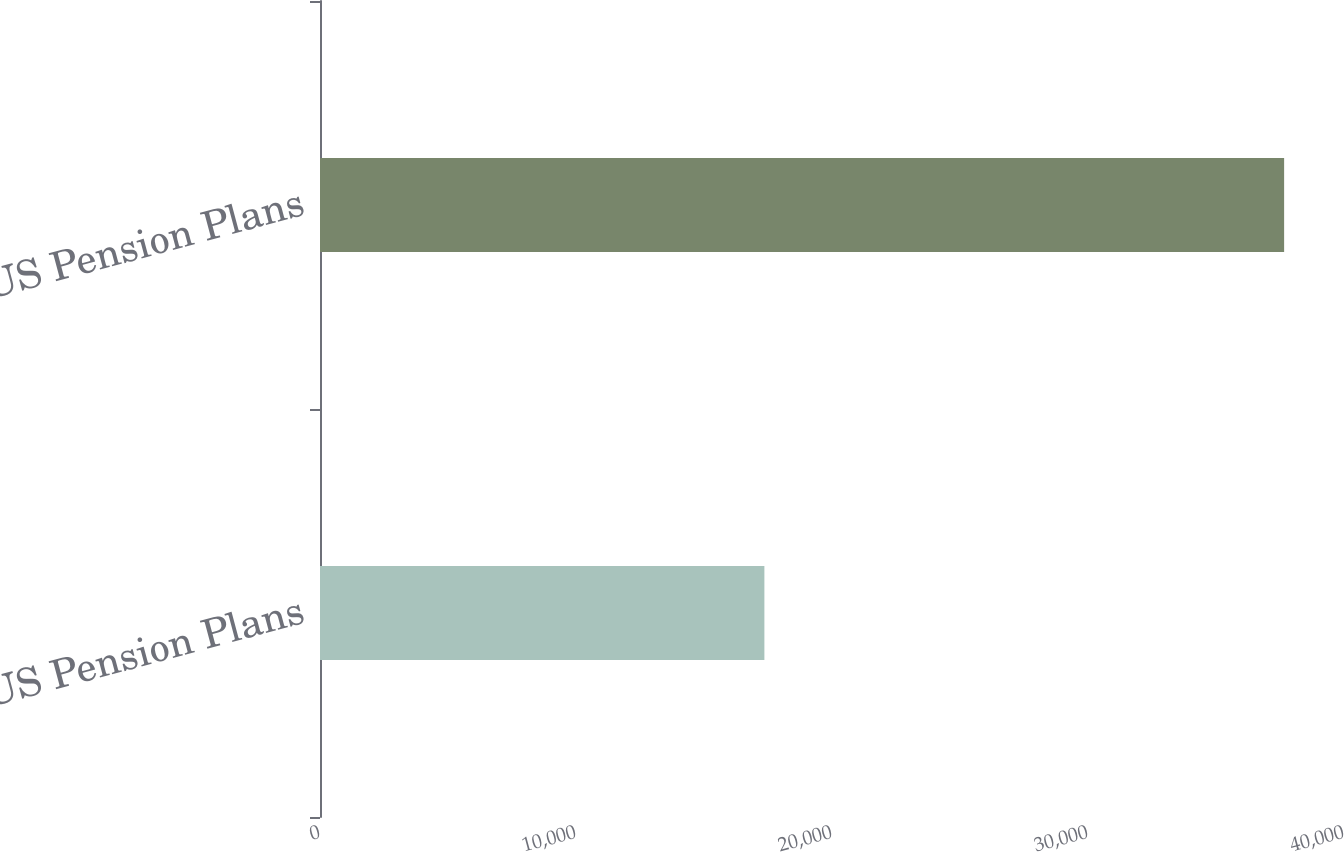Convert chart. <chart><loc_0><loc_0><loc_500><loc_500><bar_chart><fcel>US Pension Plans<fcel>Non-US Pension Plans<nl><fcel>17359<fcel>37661<nl></chart> 